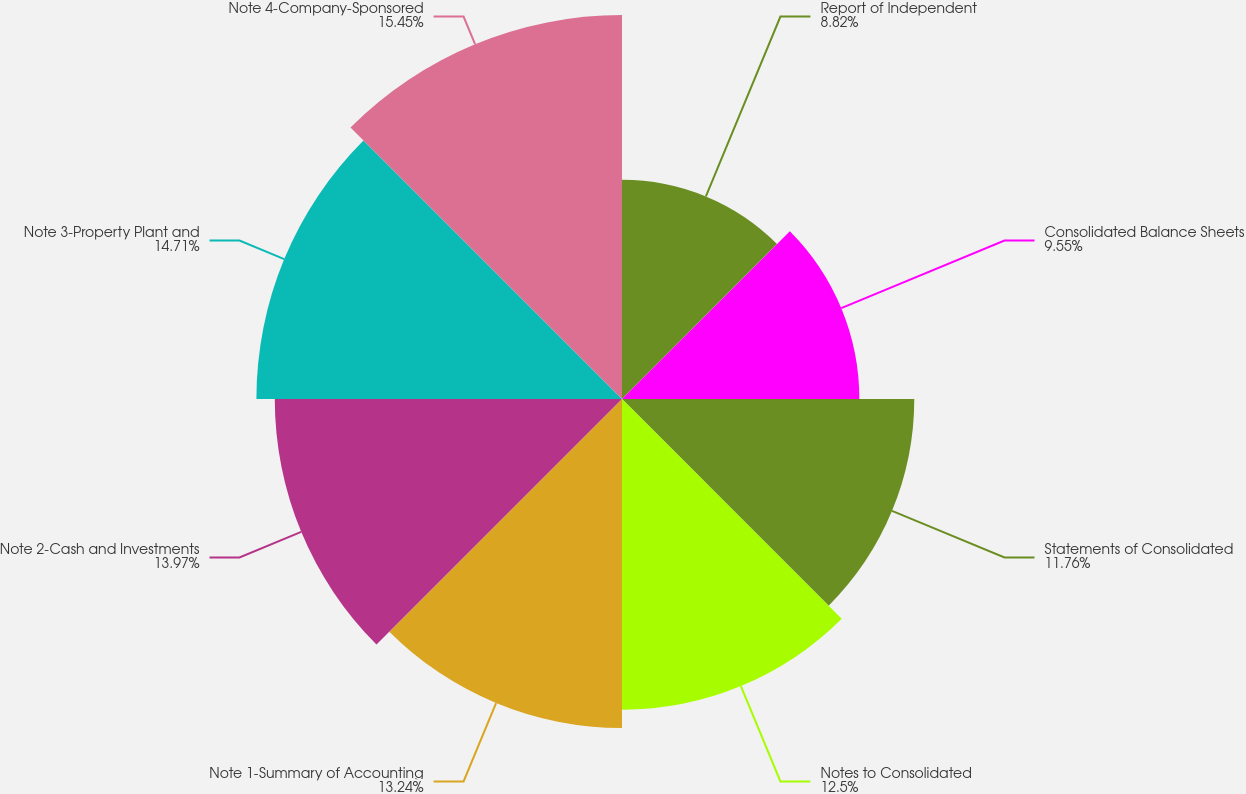Convert chart to OTSL. <chart><loc_0><loc_0><loc_500><loc_500><pie_chart><fcel>Report of Independent<fcel>Consolidated Balance Sheets<fcel>Statements of Consolidated<fcel>Notes to Consolidated<fcel>Note 1-Summary of Accounting<fcel>Note 2-Cash and Investments<fcel>Note 3-Property Plant and<fcel>Note 4-Company-Sponsored<nl><fcel>8.82%<fcel>9.55%<fcel>11.76%<fcel>12.5%<fcel>13.24%<fcel>13.97%<fcel>14.71%<fcel>15.45%<nl></chart> 